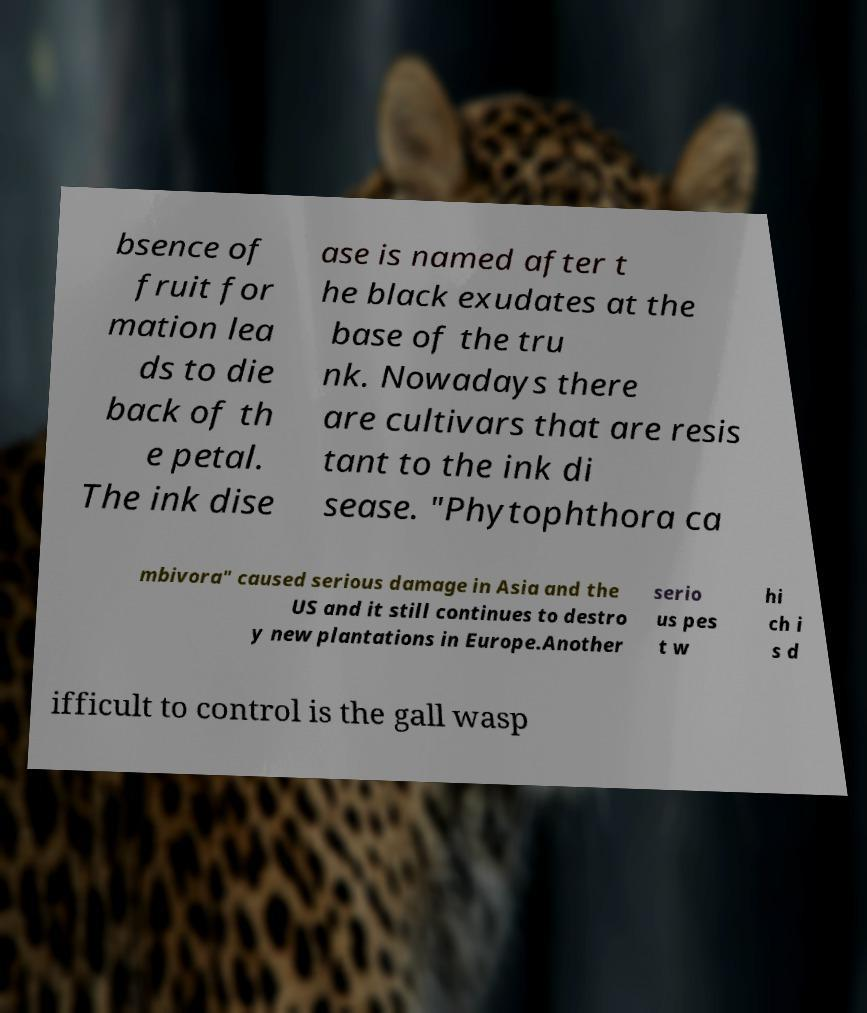Can you read and provide the text displayed in the image?This photo seems to have some interesting text. Can you extract and type it out for me? bsence of fruit for mation lea ds to die back of th e petal. The ink dise ase is named after t he black exudates at the base of the tru nk. Nowadays there are cultivars that are resis tant to the ink di sease. "Phytophthora ca mbivora" caused serious damage in Asia and the US and it still continues to destro y new plantations in Europe.Another serio us pes t w hi ch i s d ifficult to control is the gall wasp 